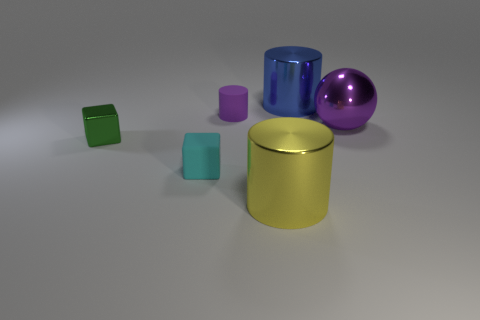What shape is the metal object that is the same color as the rubber cylinder?
Your response must be concise. Sphere. What is the size of the thing that is the same color as the metallic ball?
Give a very brief answer. Small. Do the big purple object and the tiny matte thing in front of the tiny metal thing have the same shape?
Offer a very short reply. No. Does the tiny rubber object in front of the green shiny cube have the same shape as the tiny green metallic object?
Give a very brief answer. Yes. How many shiny objects are both right of the tiny purple matte cylinder and behind the big yellow shiny thing?
Your answer should be compact. 2. How many other objects are the same size as the purple sphere?
Provide a succinct answer. 2. Is the number of large purple things in front of the metallic block the same as the number of big metallic objects?
Your answer should be compact. No. There is a small metal object that is behind the yellow object; does it have the same color as the large cylinder to the right of the large yellow metal thing?
Your response must be concise. No. What material is the cylinder that is behind the green object and on the right side of the purple rubber cylinder?
Offer a very short reply. Metal. What is the color of the small cylinder?
Keep it short and to the point. Purple. 